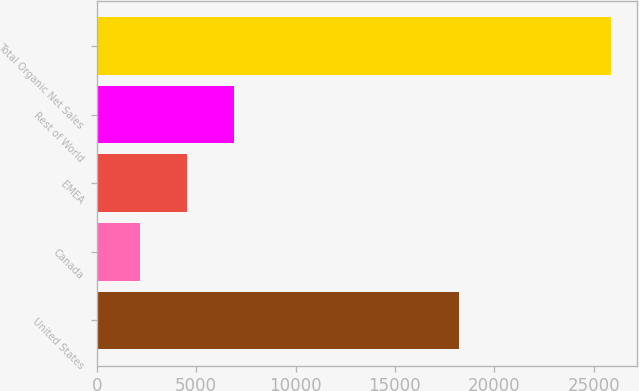<chart> <loc_0><loc_0><loc_500><loc_500><bar_chart><fcel>United States<fcel>Canada<fcel>EMEA<fcel>Rest of World<fcel>Total Organic Net Sales<nl><fcel>18230<fcel>2177<fcel>4546.9<fcel>6916.8<fcel>25876<nl></chart> 